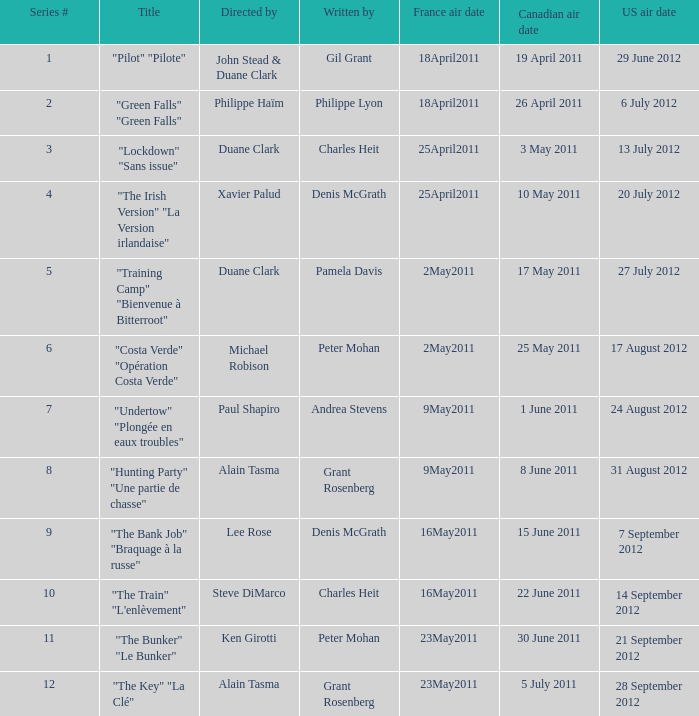What is the series # when the US air date is 20 July 2012? 4.0. 